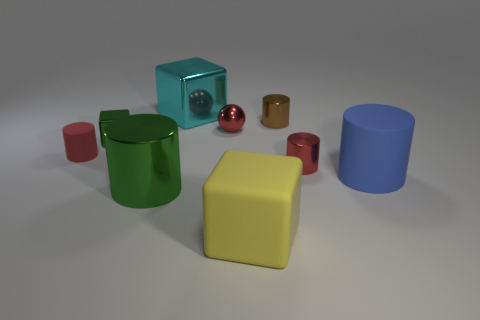Subtract all brown cylinders. How many cylinders are left? 4 Subtract all brown metal cylinders. How many cylinders are left? 4 Subtract 1 cylinders. How many cylinders are left? 4 Subtract all yellow cylinders. Subtract all yellow cubes. How many cylinders are left? 5 Add 1 green things. How many objects exist? 10 Subtract all spheres. How many objects are left? 8 Subtract all brown shiny blocks. Subtract all red objects. How many objects are left? 6 Add 7 big blue matte objects. How many big blue matte objects are left? 8 Add 6 purple shiny balls. How many purple shiny balls exist? 6 Subtract 0 purple spheres. How many objects are left? 9 